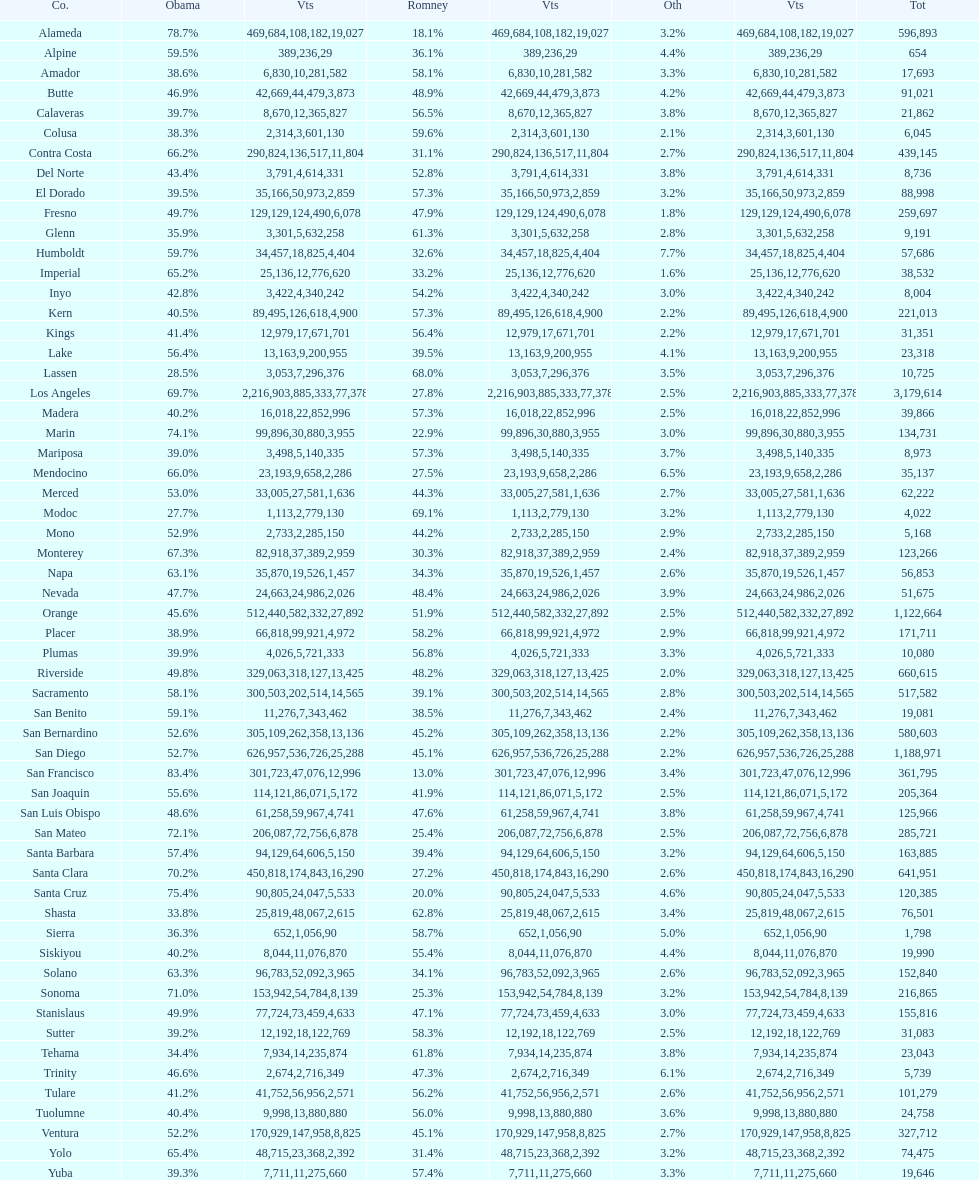Was romney's vote count in alameda county higher or lower than obama's? Less. 